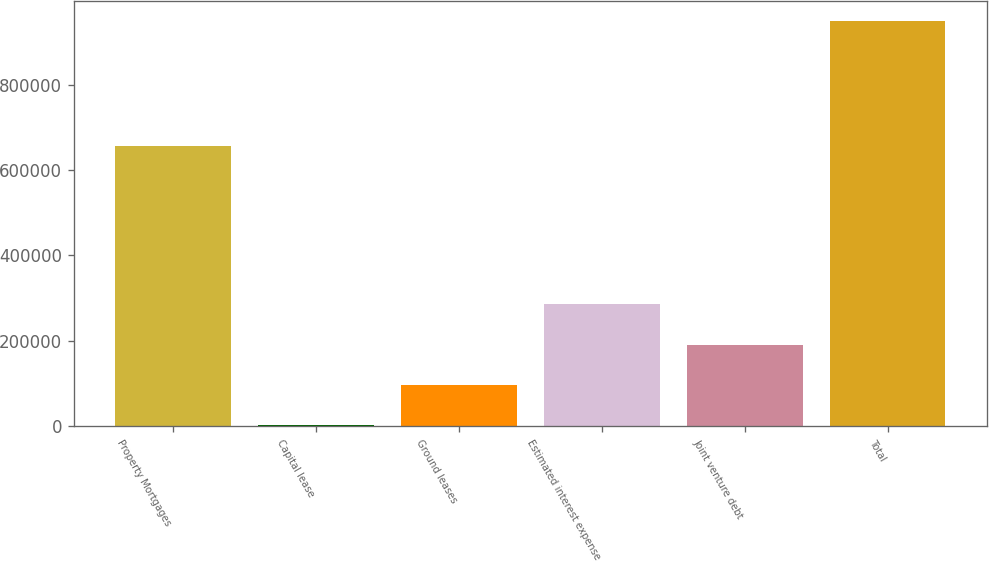<chart> <loc_0><loc_0><loc_500><loc_500><bar_chart><fcel>Property Mortgages<fcel>Capital lease<fcel>Ground leases<fcel>Estimated interest expense<fcel>Joint venture debt<fcel>Total<nl><fcel>656863<fcel>1555<fcel>96316.8<fcel>285840<fcel>191079<fcel>949173<nl></chart> 